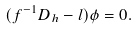<formula> <loc_0><loc_0><loc_500><loc_500>( f ^ { - 1 } D _ { h } - l ) \phi = 0 .</formula> 